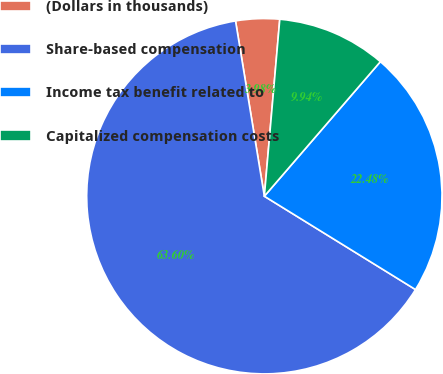<chart> <loc_0><loc_0><loc_500><loc_500><pie_chart><fcel>(Dollars in thousands)<fcel>Share-based compensation<fcel>Income tax benefit related to<fcel>Capitalized compensation costs<nl><fcel>3.98%<fcel>63.6%<fcel>22.48%<fcel>9.94%<nl></chart> 